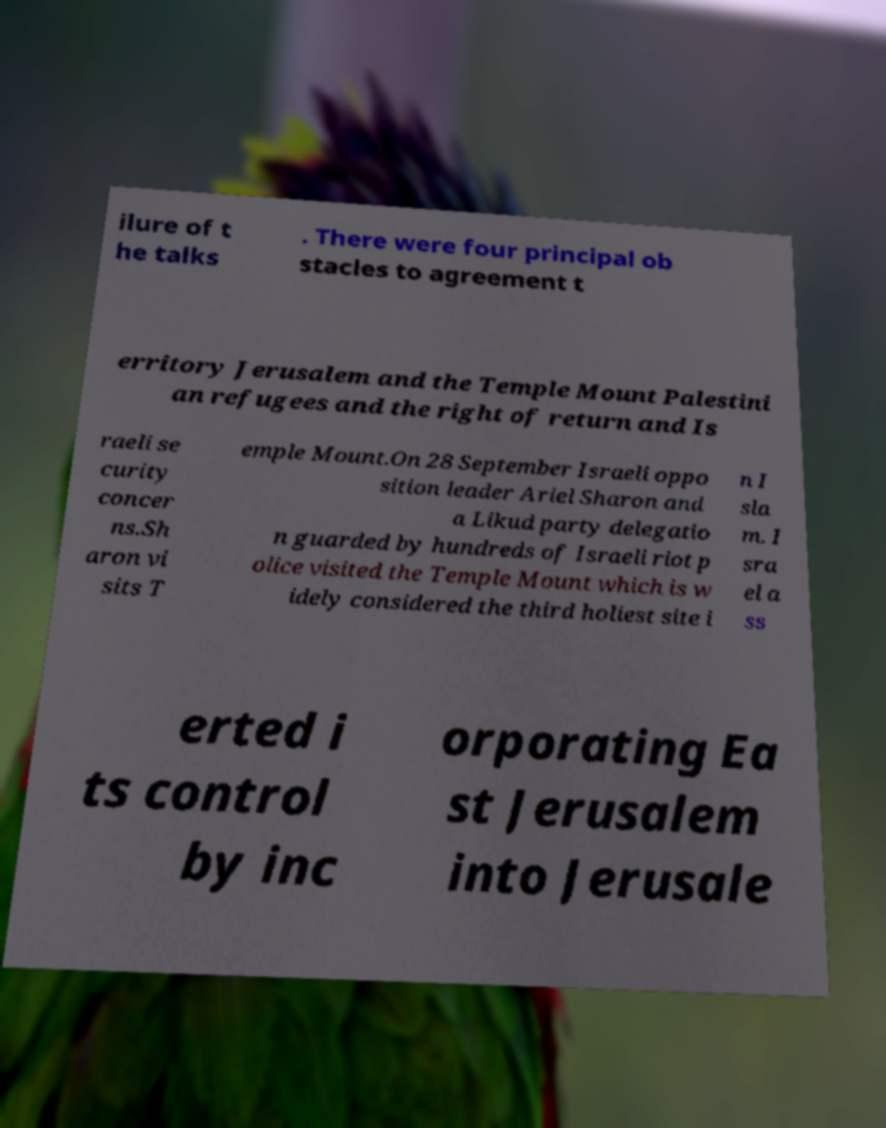Could you assist in decoding the text presented in this image and type it out clearly? ilure of t he talks . There were four principal ob stacles to agreement t erritory Jerusalem and the Temple Mount Palestini an refugees and the right of return and Is raeli se curity concer ns.Sh aron vi sits T emple Mount.On 28 September Israeli oppo sition leader Ariel Sharon and a Likud party delegatio n guarded by hundreds of Israeli riot p olice visited the Temple Mount which is w idely considered the third holiest site i n I sla m. I sra el a ss erted i ts control by inc orporating Ea st Jerusalem into Jerusale 